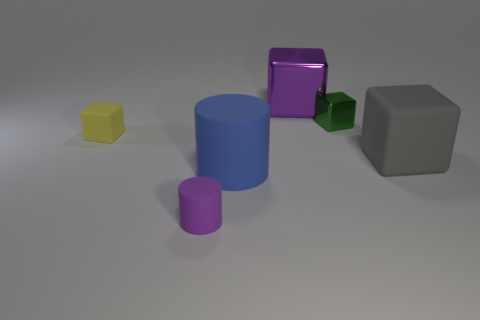Add 3 large gray matte blocks. How many objects exist? 9 Add 3 large rubber things. How many large rubber things are left? 5 Add 1 purple rubber things. How many purple rubber things exist? 2 Subtract all gray blocks. How many blocks are left? 3 Subtract all green shiny cubes. How many cubes are left? 3 Subtract 0 blue spheres. How many objects are left? 6 Subtract all cubes. How many objects are left? 2 Subtract 2 blocks. How many blocks are left? 2 Subtract all blue cylinders. Subtract all green spheres. How many cylinders are left? 1 Subtract all gray cylinders. How many cyan cubes are left? 0 